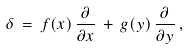<formula> <loc_0><loc_0><loc_500><loc_500>\delta \, = \, f ( x ) \, \frac { \partial } { \partial x } \, + \, g ( y ) \, \frac { \partial } { \partial y } \, ,</formula> 